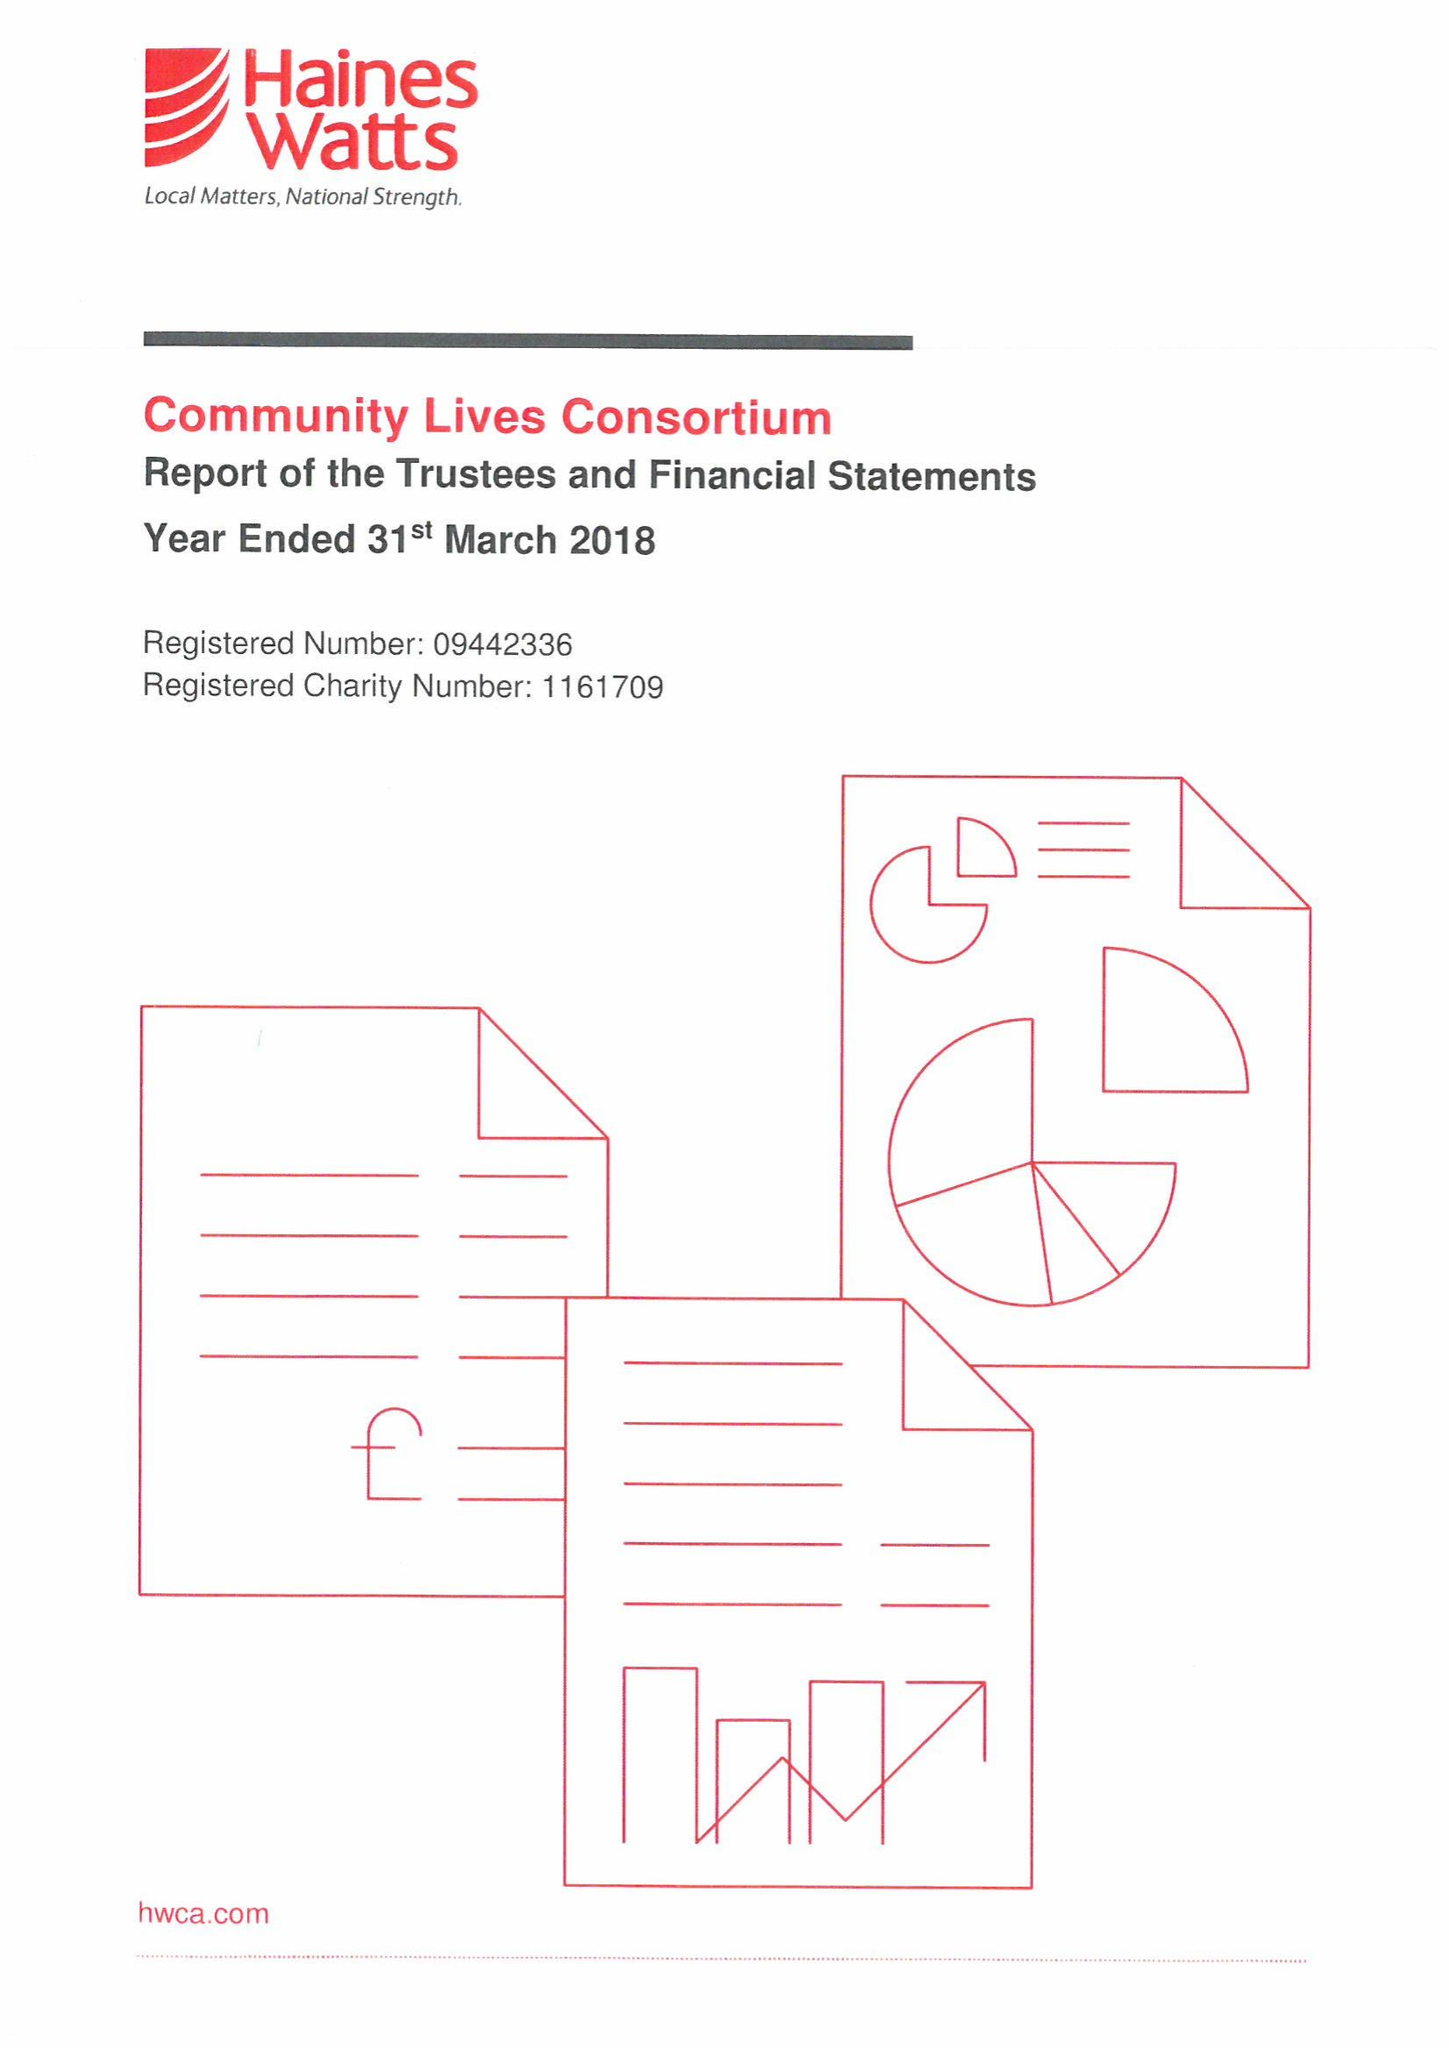What is the value for the report_date?
Answer the question using a single word or phrase. 2018-03-31 